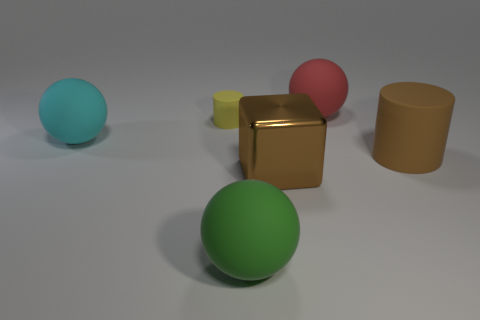Add 2 small purple cylinders. How many objects exist? 8 Subtract all brown cylinders. How many cylinders are left? 1 Subtract all cubes. How many objects are left? 5 Add 1 rubber spheres. How many rubber spheres exist? 4 Subtract 0 gray cylinders. How many objects are left? 6 Subtract all red cylinders. Subtract all cyan blocks. How many cylinders are left? 2 Subtract all small rubber cylinders. Subtract all big gray rubber cubes. How many objects are left? 5 Add 1 big cyan objects. How many big cyan objects are left? 2 